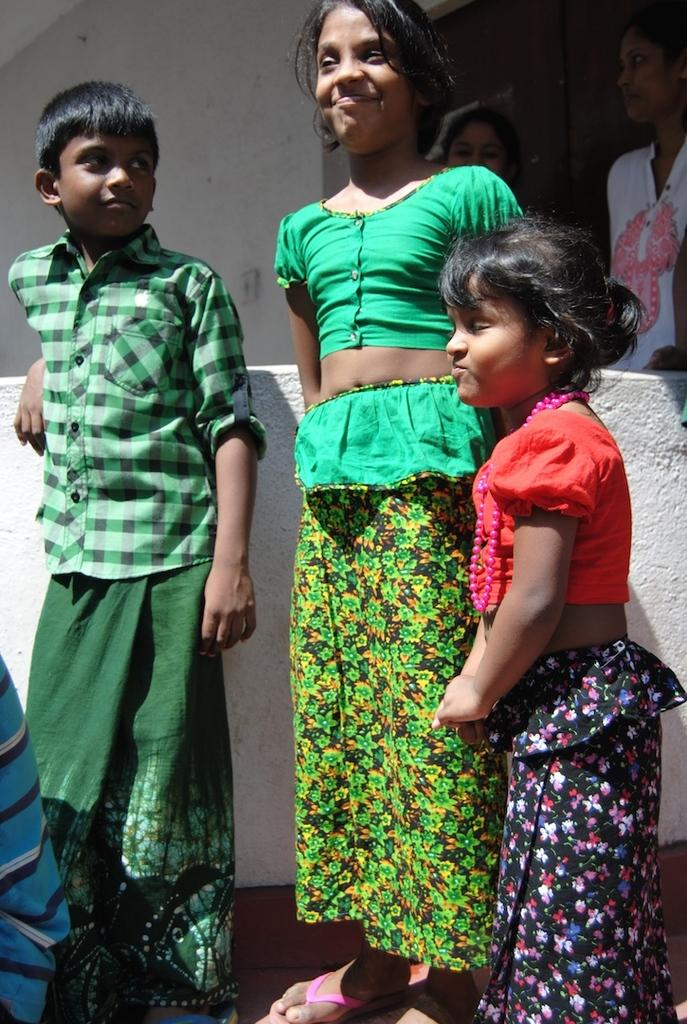How many people are present in the image? There is a group of people standing in the image, along with a person sitting. What is the position of the person sitting in the image? The person sitting is in a seated position in the image. What can be seen in the background of the image? There is a building in the background of the image. What is located on the wall in the image? There is a switch board on the wall in the image. How does the spoon contribute to the quiet atmosphere in the image? There is no spoon present in the image, and therefore it cannot contribute to the atmosphere. 